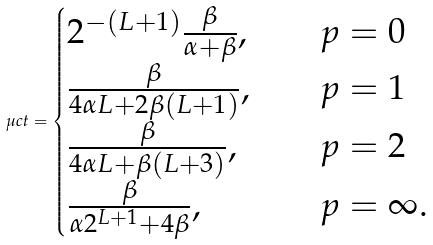Convert formula to latex. <formula><loc_0><loc_0><loc_500><loc_500>\mu c t = \begin{cases} 2 ^ { - ( L + 1 ) } \frac { \beta } { \alpha + \beta } , & \quad p = 0 \\ \frac { \beta } { 4 \alpha L + 2 \beta ( L + 1 ) } , & \quad p = 1 \\ \frac { \beta } { 4 \alpha L + \beta ( L + 3 ) } , & \quad p = 2 \\ \frac { \beta } { \alpha 2 ^ { L + 1 } + 4 \beta } , & \quad p = \infty . \end{cases}</formula> 